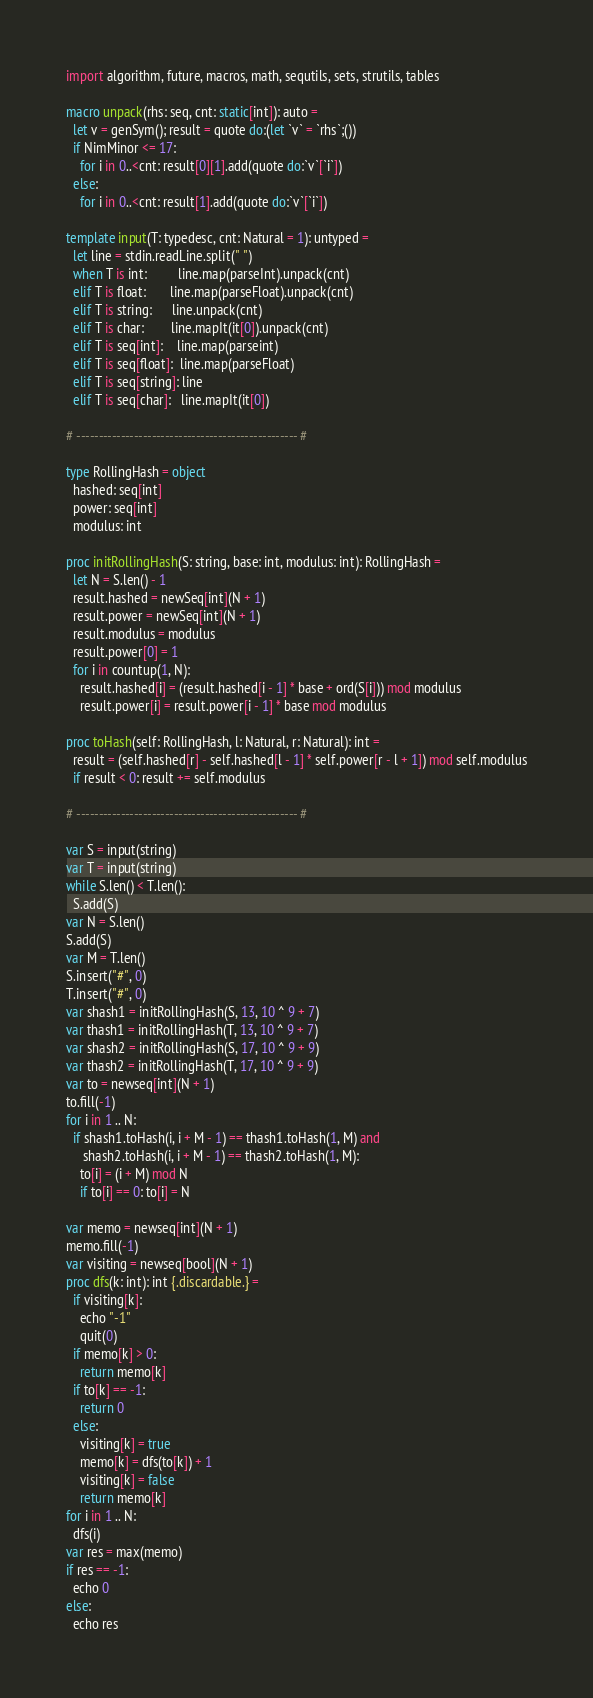<code> <loc_0><loc_0><loc_500><loc_500><_Nim_>import algorithm, future, macros, math, sequtils, sets, strutils, tables

macro unpack(rhs: seq, cnt: static[int]): auto =
  let v = genSym(); result = quote do:(let `v` = `rhs`;())
  if NimMinor <= 17:
    for i in 0..<cnt: result[0][1].add(quote do:`v`[`i`])
  else:
    for i in 0..<cnt: result[1].add(quote do:`v`[`i`])

template input(T: typedesc, cnt: Natural = 1): untyped =
  let line = stdin.readLine.split(" ")
  when T is int:         line.map(parseInt).unpack(cnt)
  elif T is float:       line.map(parseFloat).unpack(cnt)
  elif T is string:      line.unpack(cnt)
  elif T is char:        line.mapIt(it[0]).unpack(cnt)
  elif T is seq[int]:    line.map(parseint)
  elif T is seq[float]:  line.map(parseFloat)
  elif T is seq[string]: line
  elif T is seq[char]:   line.mapIt(it[0])

# -------------------------------------------------- #
 
type RollingHash = object
  hashed: seq[int]
  power: seq[int]
  modulus: int
 
proc initRollingHash(S: string, base: int, modulus: int): RollingHash =
  let N = S.len() - 1
  result.hashed = newSeq[int](N + 1)
  result.power = newSeq[int](N + 1)
  result.modulus = modulus
  result.power[0] = 1
  for i in countup(1, N):
    result.hashed[i] = (result.hashed[i - 1] * base + ord(S[i])) mod modulus
    result.power[i] = result.power[i - 1] * base mod modulus
 
proc toHash(self: RollingHash, l: Natural, r: Natural): int =
  result = (self.hashed[r] - self.hashed[l - 1] * self.power[r - l + 1]) mod self.modulus
  if result < 0: result += self.modulus
 
# -------------------------------------------------- #
 
var S = input(string)
var T = input(string)
while S.len() < T.len():
  S.add(S)
var N = S.len()
S.add(S)
var M = T.len()
S.insert("#", 0)
T.insert("#", 0)
var shash1 = initRollingHash(S, 13, 10 ^ 9 + 7)
var thash1 = initRollingHash(T, 13, 10 ^ 9 + 7)
var shash2 = initRollingHash(S, 17, 10 ^ 9 + 9)
var thash2 = initRollingHash(T, 17, 10 ^ 9 + 9)
var to = newseq[int](N + 1)
to.fill(-1)
for i in 1 .. N:
  if shash1.toHash(i, i + M - 1) == thash1.toHash(1, M) and
     shash2.toHash(i, i + M - 1) == thash2.toHash(1, M):
    to[i] = (i + M) mod N
    if to[i] == 0: to[i] = N

var memo = newseq[int](N + 1)
memo.fill(-1)
var visiting = newseq[bool](N + 1)
proc dfs(k: int): int {.discardable.} =
  if visiting[k]:
    echo "-1"
    quit(0)
  if memo[k] > 0:
    return memo[k]
  if to[k] == -1:
    return 0
  else:
    visiting[k] = true
    memo[k] = dfs(to[k]) + 1
    visiting[k] = false
    return memo[k]
for i in 1 .. N:
  dfs(i)
var res = max(memo)
if res == -1:
  echo 0
else:
  echo res</code> 